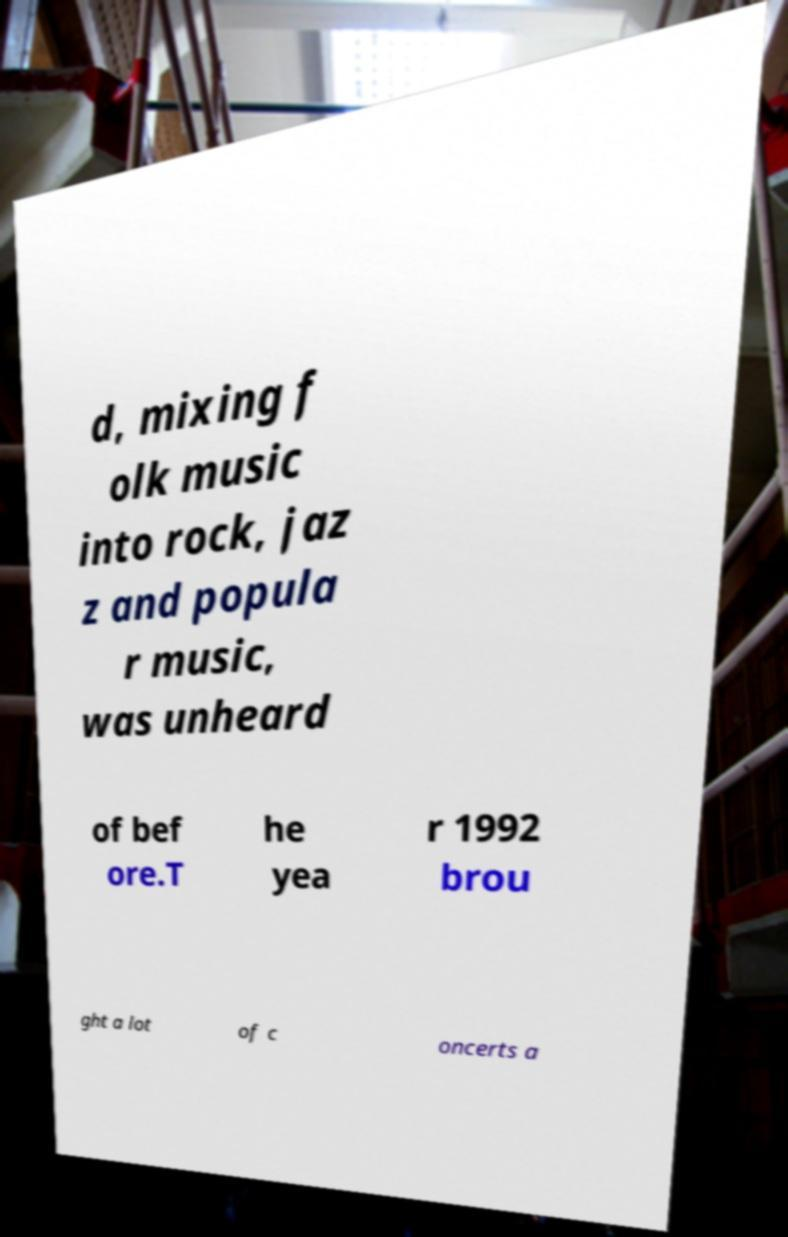Could you assist in decoding the text presented in this image and type it out clearly? d, mixing f olk music into rock, jaz z and popula r music, was unheard of bef ore.T he yea r 1992 brou ght a lot of c oncerts a 